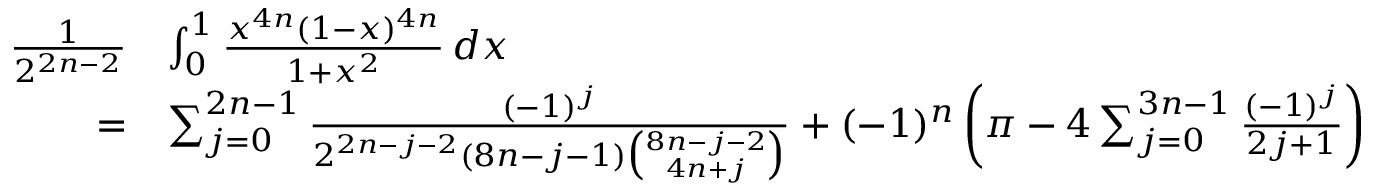<formula> <loc_0><loc_0><loc_500><loc_500>{ \begin{array} { r l } { { \frac { 1 } { 2 ^ { 2 n - 2 } } } } & { \int _ { 0 } ^ { 1 } { \frac { x ^ { 4 n } ( 1 - x ) ^ { 4 n } } { 1 + x ^ { 2 } } } \, d x } \\ { = } & { \sum _ { j = 0 } ^ { 2 n - 1 } { \frac { ( - 1 ) ^ { j } } { 2 ^ { 2 n - j - 2 } ( 8 n - j - 1 ) { \binom { 8 n - j - 2 } { 4 n + j } } } } + ( - 1 ) ^ { n } \left ( \pi - 4 \sum _ { j = 0 } ^ { 3 n - 1 } { \frac { ( - 1 ) ^ { j } } { 2 j + 1 } } \right ) } \end{array} }</formula> 